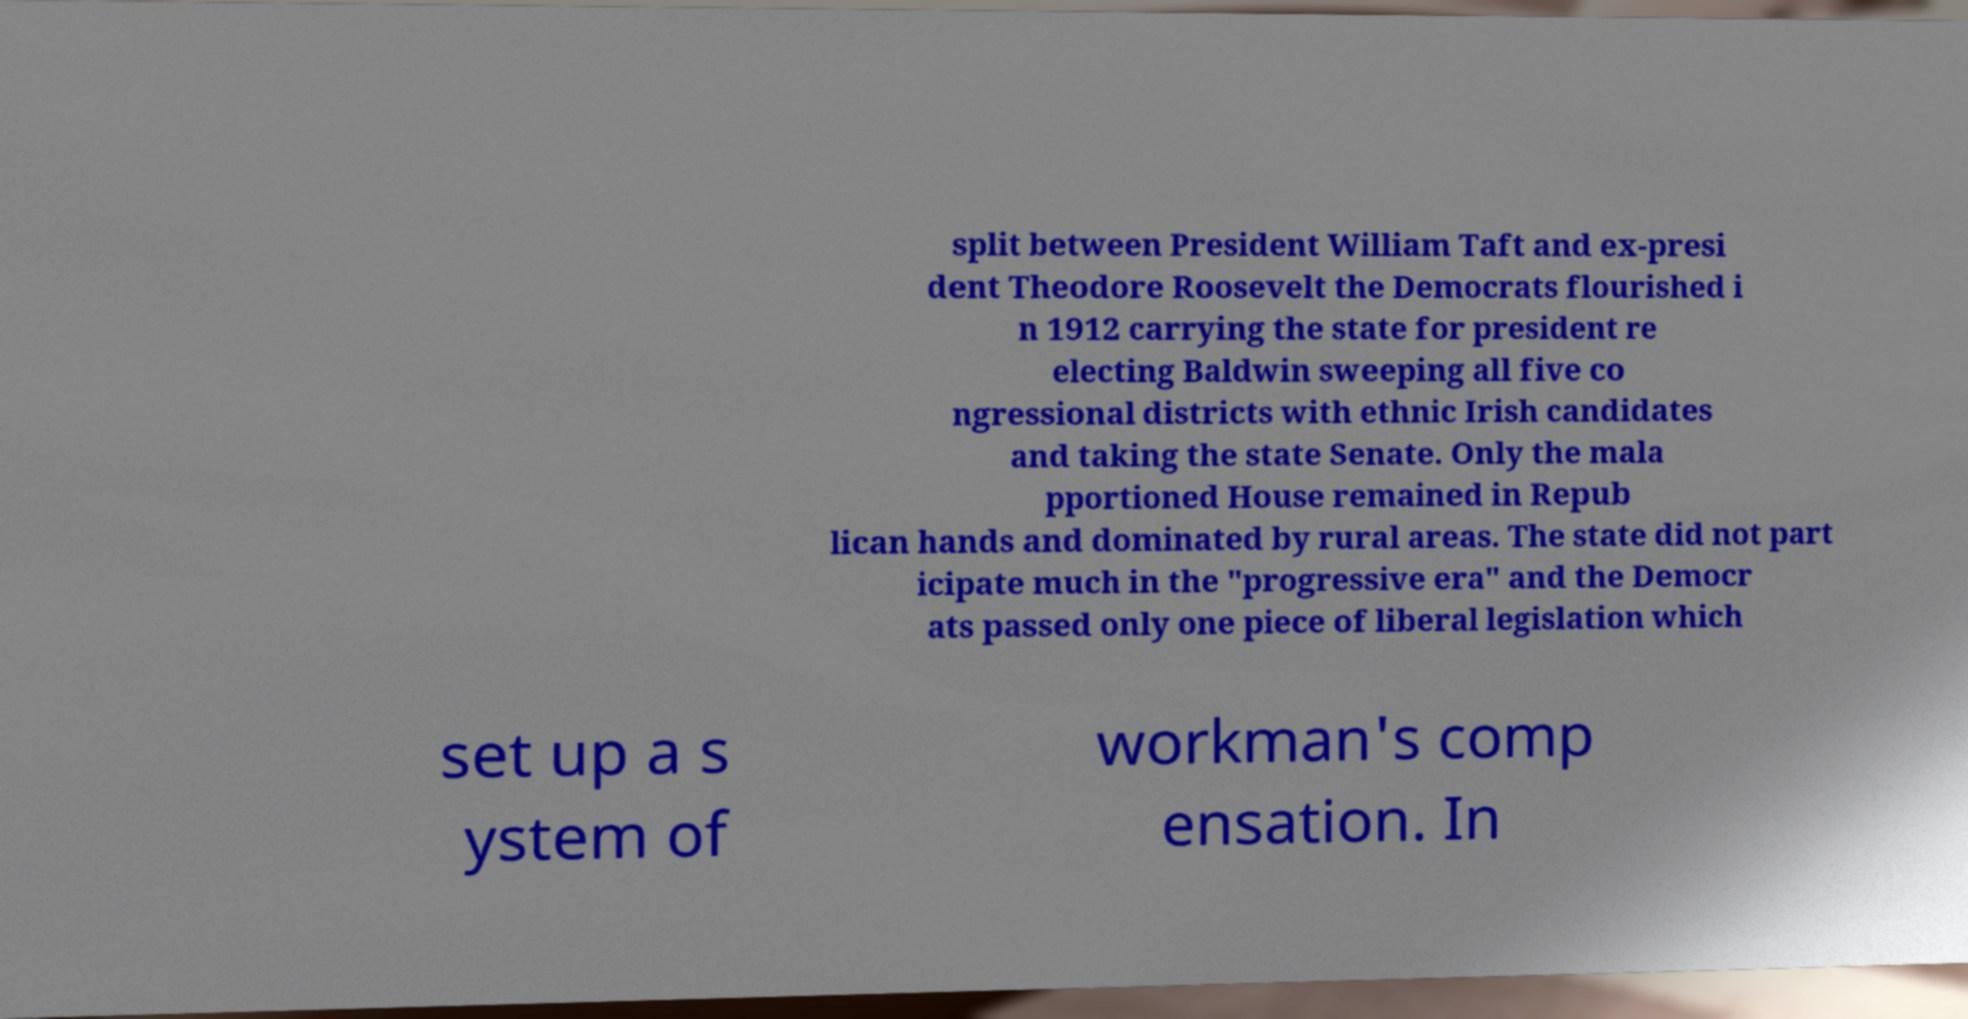Could you extract and type out the text from this image? split between President William Taft and ex-presi dent Theodore Roosevelt the Democrats flourished i n 1912 carrying the state for president re electing Baldwin sweeping all five co ngressional districts with ethnic Irish candidates and taking the state Senate. Only the mala pportioned House remained in Repub lican hands and dominated by rural areas. The state did not part icipate much in the "progressive era" and the Democr ats passed only one piece of liberal legislation which set up a s ystem of workman's comp ensation. In 